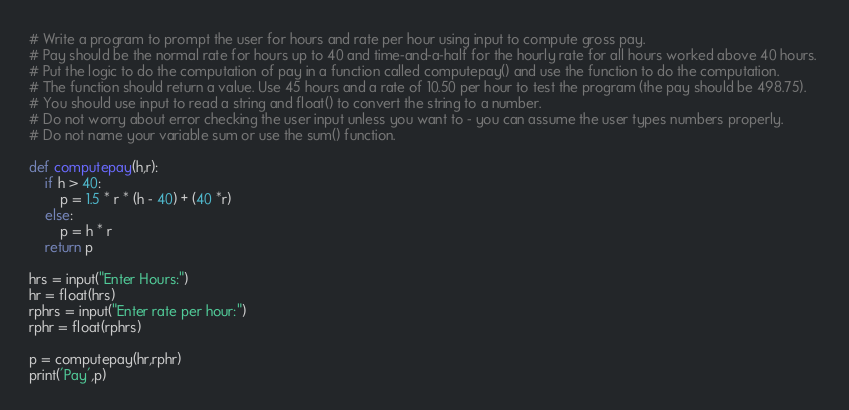Convert code to text. <code><loc_0><loc_0><loc_500><loc_500><_Python_># Write a program to prompt the user for hours and rate per hour using input to compute gross pay. 
# Pay should be the normal rate for hours up to 40 and time-and-a-half for the hourly rate for all hours worked above 40 hours. 
# Put the logic to do the computation of pay in a function called computepay() and use the function to do the computation. 
# The function should return a value. Use 45 hours and a rate of 10.50 per hour to test the program (the pay should be 498.75). 
# You should use input to read a string and float() to convert the string to a number. 
# Do not worry about error checking the user input unless you want to - you can assume the user types numbers properly.
# Do not name your variable sum or use the sum() function.

def computepay(h,r):
    if h > 40:
        p = 1.5 * r * (h - 40) + (40 *r)
    else:
        p = h * r
    return p
    
hrs = input("Enter Hours:")
hr = float(hrs)
rphrs = input("Enter rate per hour:")
rphr = float(rphrs)

p = computepay(hr,rphr)
print('Pay',p)
</code> 